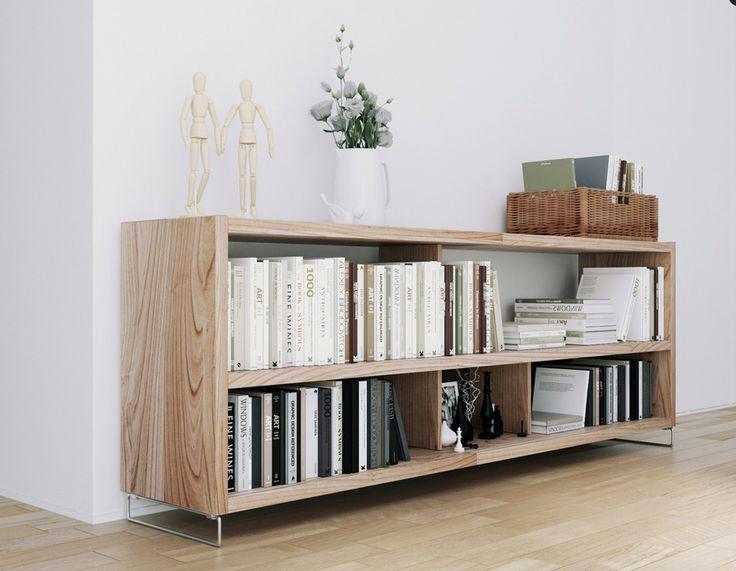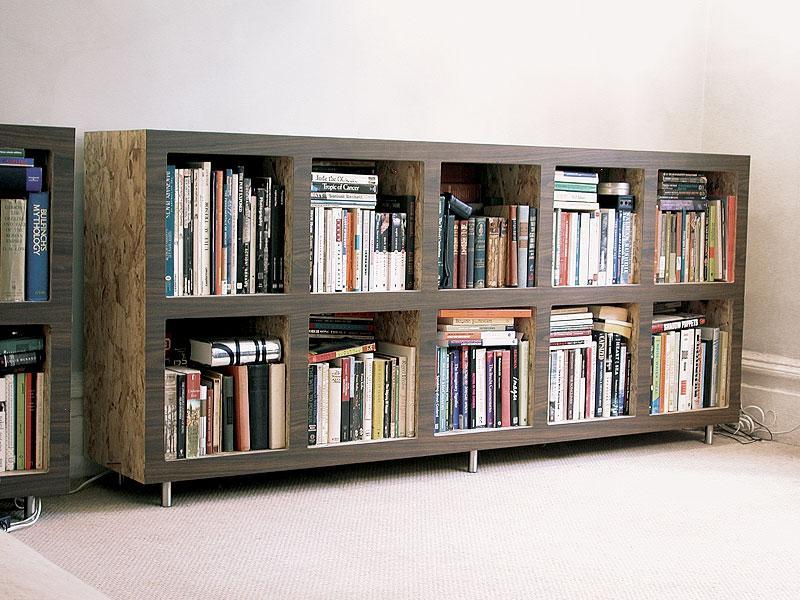The first image is the image on the left, the second image is the image on the right. Given the left and right images, does the statement "The bookshelf in the image on the left is sitting against a white wall." hold true? Answer yes or no. Yes. The first image is the image on the left, the second image is the image on the right. Analyze the images presented: Is the assertion "At least one image shows a white low bookshelf unit that sits flush on the ground and has a variety of items displayed on its top." valid? Answer yes or no. No. 